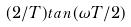Convert formula to latex. <formula><loc_0><loc_0><loc_500><loc_500>( 2 / T ) t a n ( \omega T / 2 )</formula> 